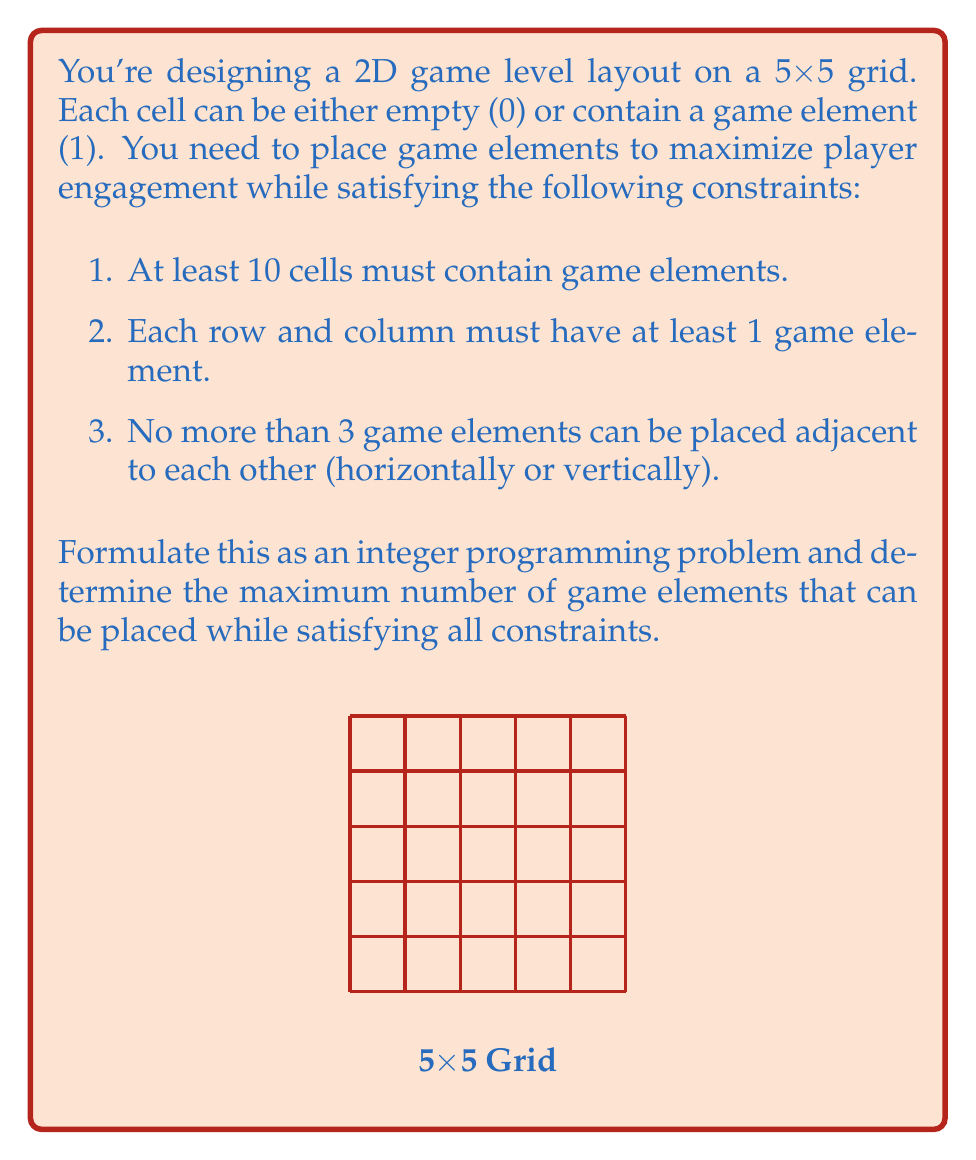Give your solution to this math problem. Let's approach this step-by-step:

1) Define decision variables:
   Let $x_{ij}$ be a binary variable where $i,j \in \{1,2,3,4,5\}$
   $x_{ij} = 1$ if a game element is placed in cell $(i,j)$, 0 otherwise

2) Objective function:
   Maximize the number of game elements:
   $$\text{Maximize } Z = \sum_{i=1}^5 \sum_{j=1}^5 x_{ij}$$

3) Constraints:
   a) At least 10 cells must contain game elements:
      $$\sum_{i=1}^5 \sum_{j=1}^5 x_{ij} \geq 10$$

   b) Each row must have at least 1 game element:
      $$\sum_{j=1}^5 x_{ij} \geq 1 \quad \forall i \in \{1,2,3,4,5\}$$

   c) Each column must have at least 1 game element:
      $$\sum_{i=1}^5 x_{ij} \geq 1 \quad \forall j \in \{1,2,3,4,5\}$$

   d) No more than 3 adjacent game elements horizontally:
      $$x_{ij} + x_{i,j+1} + x_{i,j+2} + x_{i,j+3} \leq 3 \quad \forall i \in \{1,2,3,4,5\}, j \in \{1,2,3\}$$

   e) No more than 3 adjacent game elements vertically:
      $$x_{ij} + x_{i+1,j} + x_{i+2,j} + x_{i+3,j} \leq 3 \quad \forall i \in \{1,2,3\}, j \in \{1,2,3,4,5\}$$

4) Binary constraint:
   $$x_{ij} \in \{0,1\} \quad \forall i,j \in \{1,2,3,4,5\}$$

Solving this integer programming problem would give us the maximum number of game elements that can be placed while satisfying all constraints.

The maximum number of game elements that can be placed is 13. One possible optimal layout is:

[asy]
unitsize(30);
for(int i=0; i<6; ++i) {
  draw((0,i)--(5,i));
  draw((i,0)--(i,5));
}
label("1", (0.5,4.5));
label("0", (1.5,4.5));
label("1", (2.5,4.5));
label("0", (3.5,4.5));
label("1", (4.5,4.5));
label("0", (0.5,3.5));
label("1", (1.5,3.5));
label("0", (2.5,3.5));
label("1", (3.5,3.5));
label("0", (4.5,3.5));
label("1", (0.5,2.5));
label("0", (1.5,2.5));
label("1", (2.5,2.5));
label("0", (3.5,2.5));
label("1", (4.5,2.5));
label("0", (0.5,1.5));
label("1", (1.5,1.5));
label("0", (2.5,1.5));
label("1", (3.5,1.5));
label("0", (4.5,1.5));
label("1", (0.5,0.5));
label("0", (1.5,0.5));
label("1", (2.5,0.5));
label("0", (3.5,0.5));
label("1", (4.5,0.5));
[/asy]

This layout satisfies all constraints and maximizes the number of game elements.
Answer: 13 game elements 